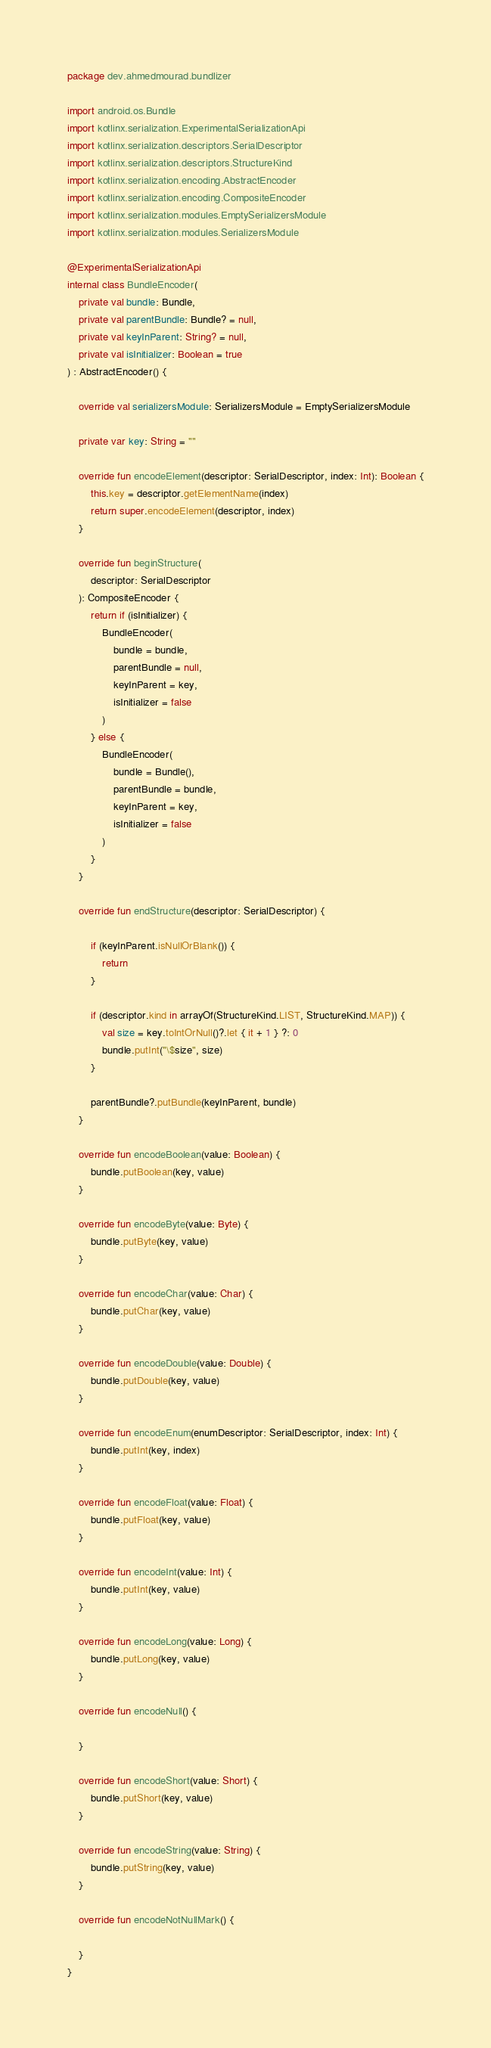<code> <loc_0><loc_0><loc_500><loc_500><_Kotlin_>package dev.ahmedmourad.bundlizer

import android.os.Bundle
import kotlinx.serialization.ExperimentalSerializationApi
import kotlinx.serialization.descriptors.SerialDescriptor
import kotlinx.serialization.descriptors.StructureKind
import kotlinx.serialization.encoding.AbstractEncoder
import kotlinx.serialization.encoding.CompositeEncoder
import kotlinx.serialization.modules.EmptySerializersModule
import kotlinx.serialization.modules.SerializersModule

@ExperimentalSerializationApi
internal class BundleEncoder(
    private val bundle: Bundle,
    private val parentBundle: Bundle? = null,
    private val keyInParent: String? = null,
    private val isInitializer: Boolean = true
) : AbstractEncoder() {

    override val serializersModule: SerializersModule = EmptySerializersModule

    private var key: String = ""

    override fun encodeElement(descriptor: SerialDescriptor, index: Int): Boolean {
        this.key = descriptor.getElementName(index)
        return super.encodeElement(descriptor, index)
    }

    override fun beginStructure(
        descriptor: SerialDescriptor
    ): CompositeEncoder {
        return if (isInitializer) {
            BundleEncoder(
                bundle = bundle,
                parentBundle = null,
                keyInParent = key,
                isInitializer = false
            )
        } else {
            BundleEncoder(
                bundle = Bundle(),
                parentBundle = bundle,
                keyInParent = key,
                isInitializer = false
            )
        }
    }

    override fun endStructure(descriptor: SerialDescriptor) {

        if (keyInParent.isNullOrBlank()) {
            return
        }

        if (descriptor.kind in arrayOf(StructureKind.LIST, StructureKind.MAP)) {
            val size = key.toIntOrNull()?.let { it + 1 } ?: 0
            bundle.putInt("\$size", size)
        }

        parentBundle?.putBundle(keyInParent, bundle)
    }

    override fun encodeBoolean(value: Boolean) {
        bundle.putBoolean(key, value)
    }

    override fun encodeByte(value: Byte) {
        bundle.putByte(key, value)
    }

    override fun encodeChar(value: Char) {
        bundle.putChar(key, value)
    }

    override fun encodeDouble(value: Double) {
        bundle.putDouble(key, value)
    }

    override fun encodeEnum(enumDescriptor: SerialDescriptor, index: Int) {
        bundle.putInt(key, index)
    }

    override fun encodeFloat(value: Float) {
        bundle.putFloat(key, value)
    }

    override fun encodeInt(value: Int) {
        bundle.putInt(key, value)
    }

    override fun encodeLong(value: Long) {
        bundle.putLong(key, value)
    }

    override fun encodeNull() {

    }

    override fun encodeShort(value: Short) {
        bundle.putShort(key, value)
    }

    override fun encodeString(value: String) {
        bundle.putString(key, value)
    }

    override fun encodeNotNullMark() {

    }
}
</code> 